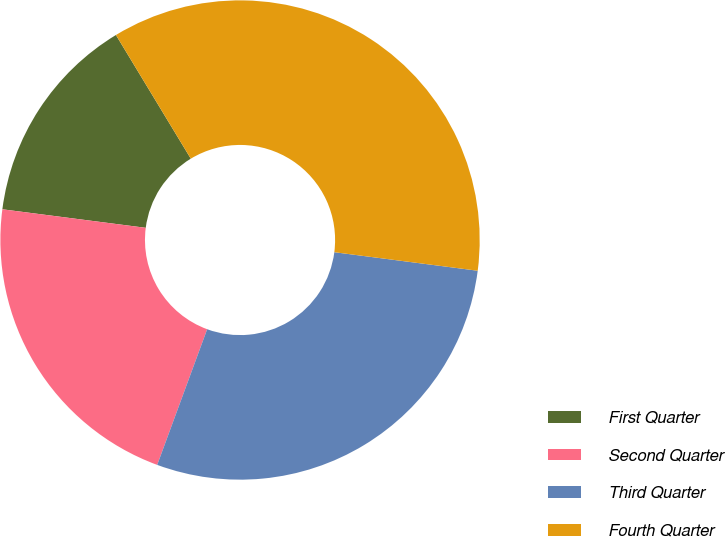<chart> <loc_0><loc_0><loc_500><loc_500><pie_chart><fcel>First Quarter<fcel>Second Quarter<fcel>Third Quarter<fcel>Fourth Quarter<nl><fcel>14.29%<fcel>21.43%<fcel>28.57%<fcel>35.71%<nl></chart> 